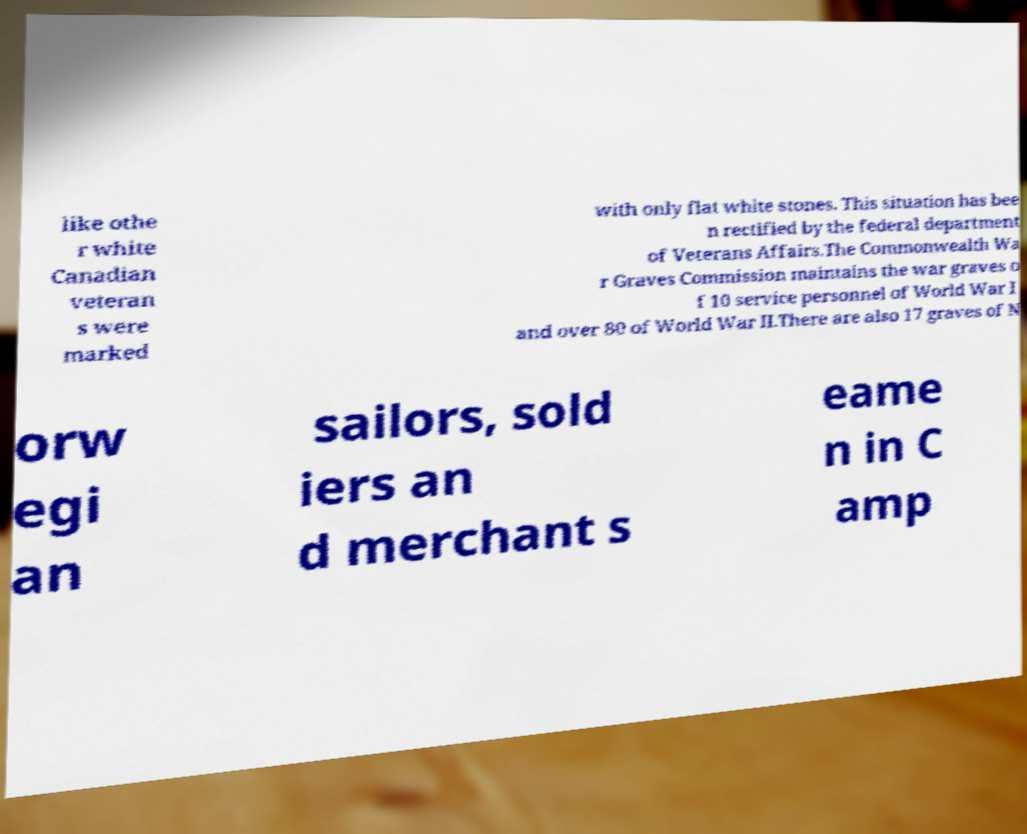I need the written content from this picture converted into text. Can you do that? like othe r white Canadian veteran s were marked with only flat white stones. This situation has bee n rectified by the federal department of Veterans Affairs.The Commonwealth Wa r Graves Commission maintains the war graves o f 10 service personnel of World War I and over 80 of World War II.There are also 17 graves of N orw egi an sailors, sold iers an d merchant s eame n in C amp 